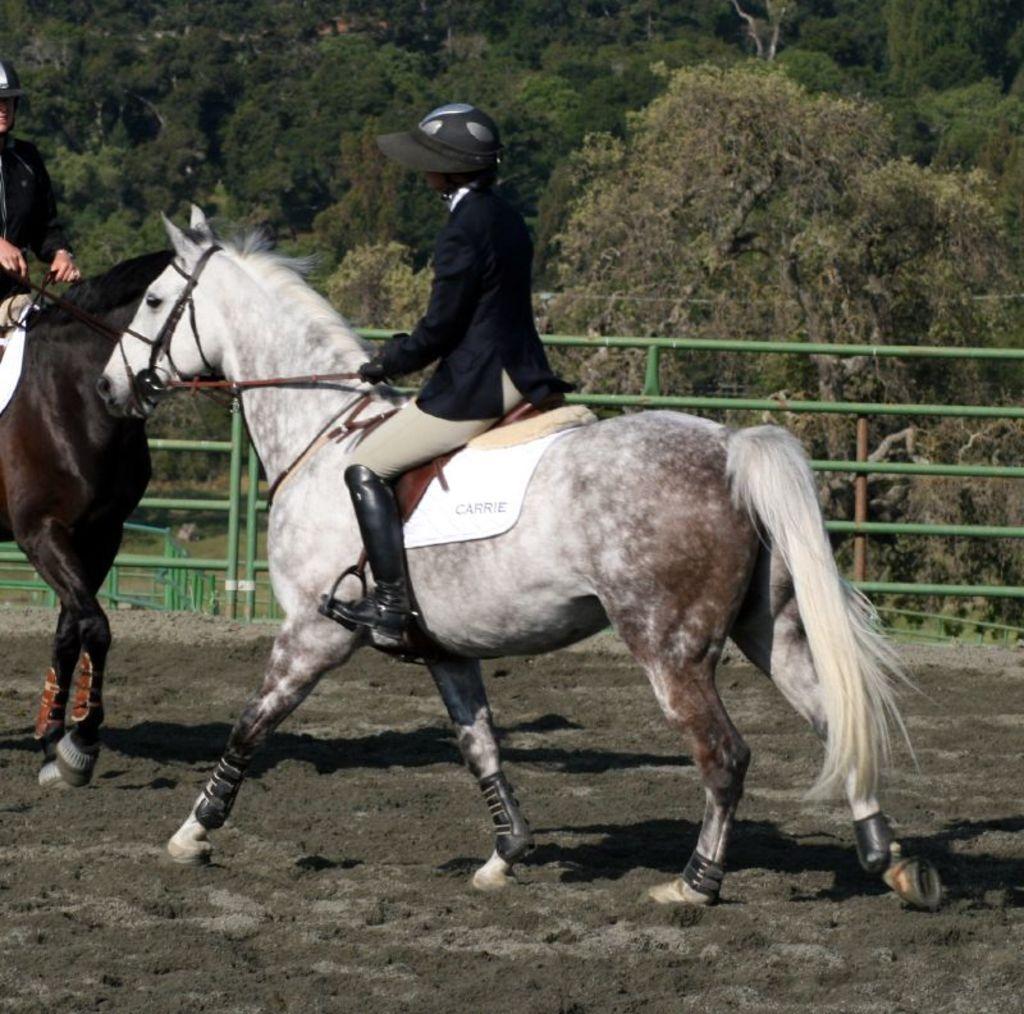Can you describe this image briefly? In this image, I can see two people riding two horses. These are the kind of barricades, which are green in color. I can see the trees. This is the mud. 